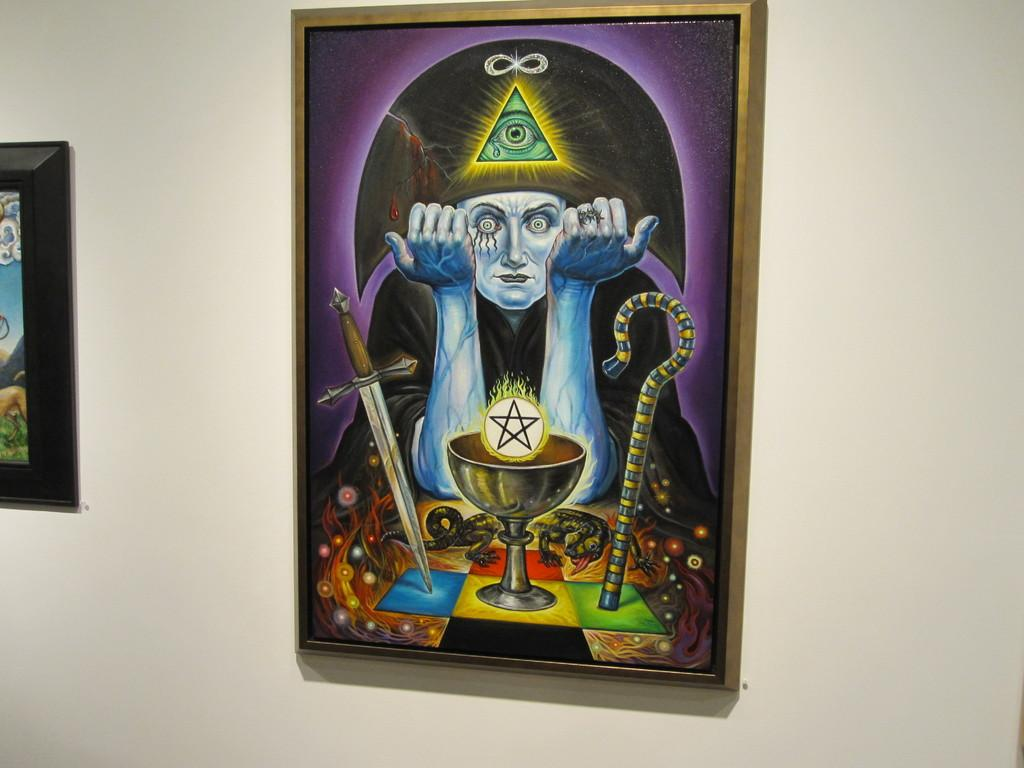What is depicted in the image? There is a painting in the image. What is the subject of the painting? The painting is of a ghost. Where is the painting located? The painting is on a wall. What type of pest can be seen crawling on the painting in the image? There are no pests visible in the image; it only features a painting of a ghost on a wall. 